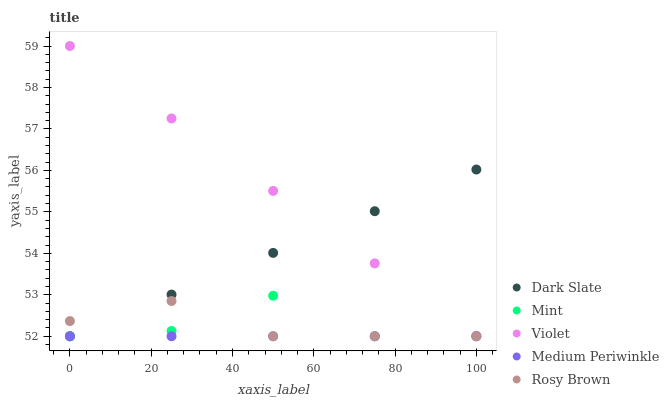Does Medium Periwinkle have the minimum area under the curve?
Answer yes or no. Yes. Does Violet have the maximum area under the curve?
Answer yes or no. Yes. Does Rosy Brown have the minimum area under the curve?
Answer yes or no. No. Does Rosy Brown have the maximum area under the curve?
Answer yes or no. No. Is Medium Periwinkle the smoothest?
Answer yes or no. Yes. Is Mint the roughest?
Answer yes or no. Yes. Is Rosy Brown the smoothest?
Answer yes or no. No. Is Rosy Brown the roughest?
Answer yes or no. No. Does Dark Slate have the lowest value?
Answer yes or no. Yes. Does Violet have the lowest value?
Answer yes or no. No. Does Violet have the highest value?
Answer yes or no. Yes. Does Rosy Brown have the highest value?
Answer yes or no. No. Is Mint less than Violet?
Answer yes or no. Yes. Is Violet greater than Medium Periwinkle?
Answer yes or no. Yes. Does Dark Slate intersect Rosy Brown?
Answer yes or no. Yes. Is Dark Slate less than Rosy Brown?
Answer yes or no. No. Is Dark Slate greater than Rosy Brown?
Answer yes or no. No. Does Mint intersect Violet?
Answer yes or no. No. 